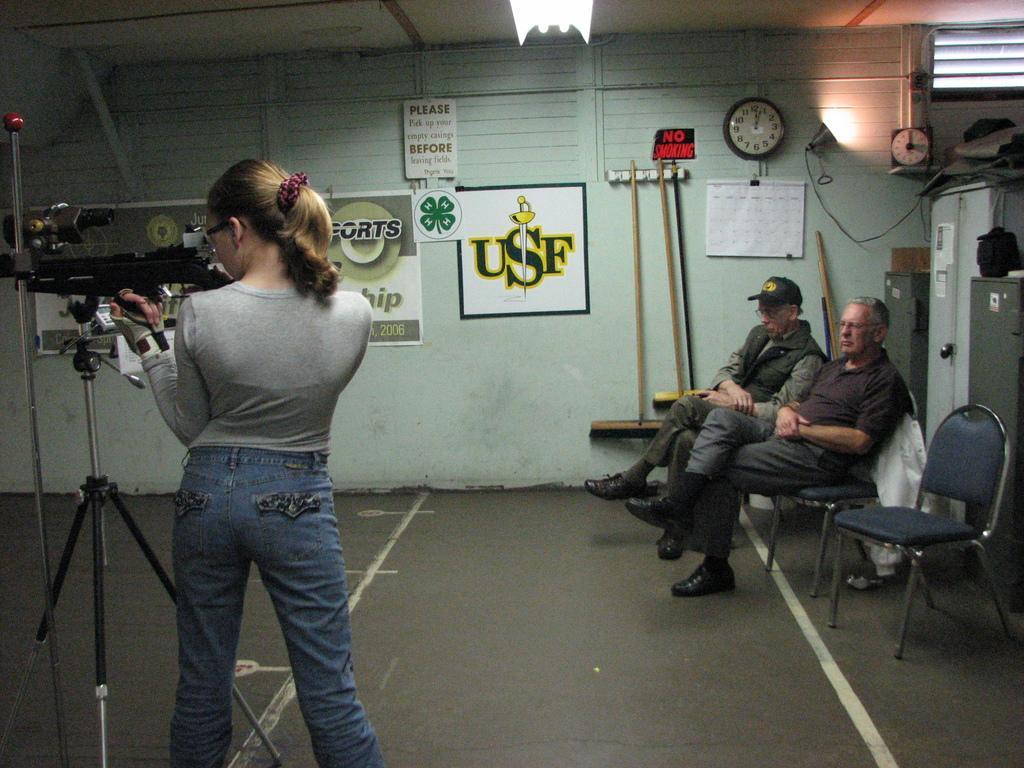Can you describe this image briefly? Here we see a woman standing and holding a gun in her hand we see two men seated on the chair and watching and we see a wall clock and poster on the wall. 